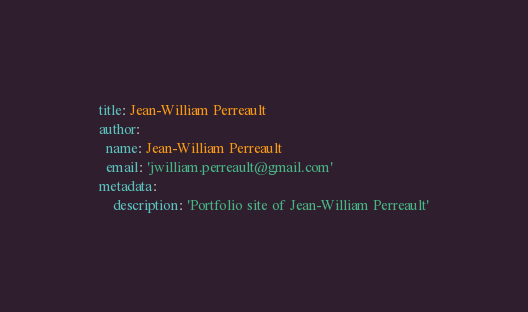Convert code to text. <code><loc_0><loc_0><loc_500><loc_500><_YAML_>title: Jean-William Perreault
author:
  name: Jean-William Perreault
  email: 'jwilliam.perreault@gmail.com'
metadata:
    description: 'Portfolio site of Jean-William Perreault'

</code> 